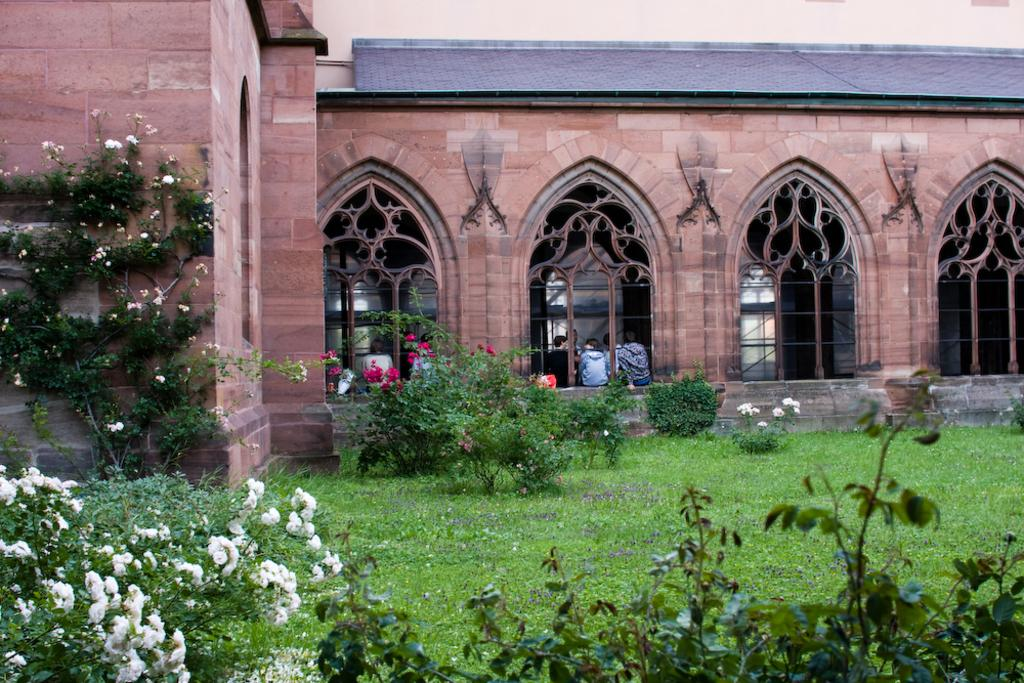What type of structure is visible in the image? There is a building with windows in the image. Can you describe the people visible in the image? There are people visible in the image. What can be seen beneath the building in the image? The ground is visible in the image, and grass is present on the ground. What type of vegetation is present in the image? Plants and flowers are present in the image. In which direction are the people in the image laughing? There is no indication in the image that the people are laughing, so it cannot be determined from the image. 